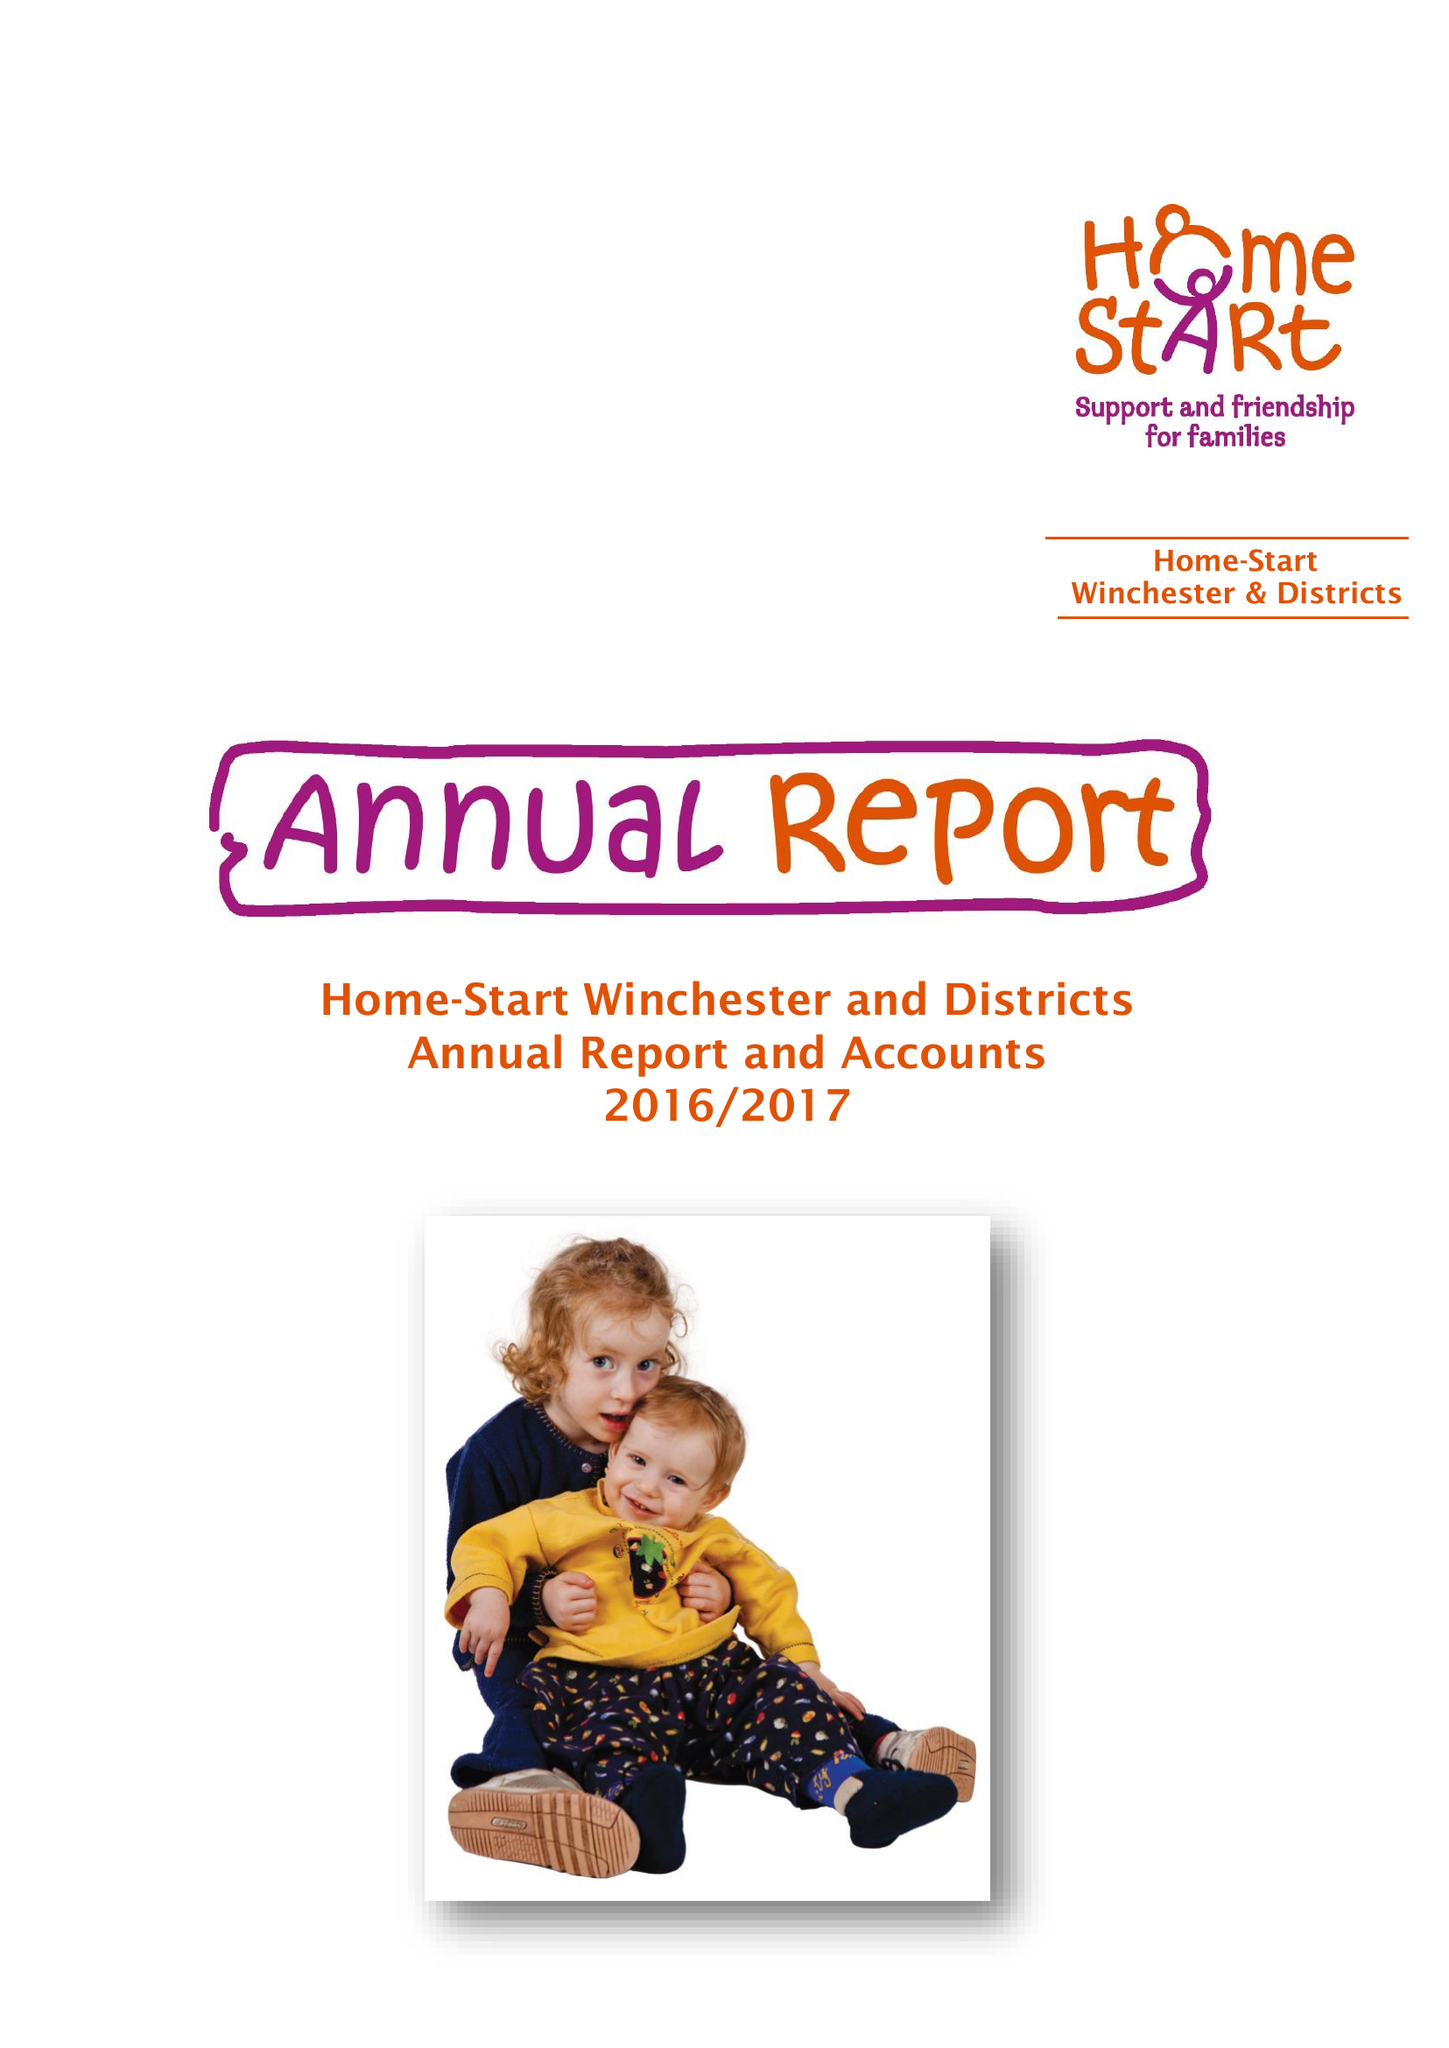What is the value for the address__post_town?
Answer the question using a single word or phrase. WINCHESTER 